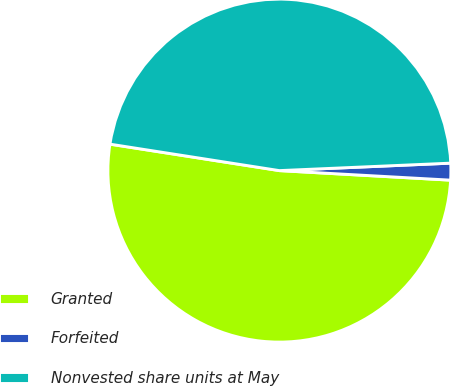Convert chart to OTSL. <chart><loc_0><loc_0><loc_500><loc_500><pie_chart><fcel>Granted<fcel>Forfeited<fcel>Nonvested share units at May<nl><fcel>51.58%<fcel>1.58%<fcel>46.84%<nl></chart> 